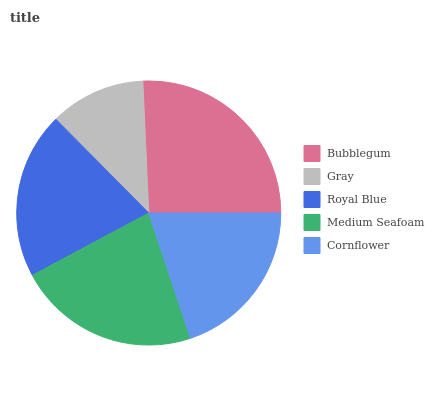Is Gray the minimum?
Answer yes or no. Yes. Is Bubblegum the maximum?
Answer yes or no. Yes. Is Royal Blue the minimum?
Answer yes or no. No. Is Royal Blue the maximum?
Answer yes or no. No. Is Royal Blue greater than Gray?
Answer yes or no. Yes. Is Gray less than Royal Blue?
Answer yes or no. Yes. Is Gray greater than Royal Blue?
Answer yes or no. No. Is Royal Blue less than Gray?
Answer yes or no. No. Is Royal Blue the high median?
Answer yes or no. Yes. Is Royal Blue the low median?
Answer yes or no. Yes. Is Gray the high median?
Answer yes or no. No. Is Gray the low median?
Answer yes or no. No. 